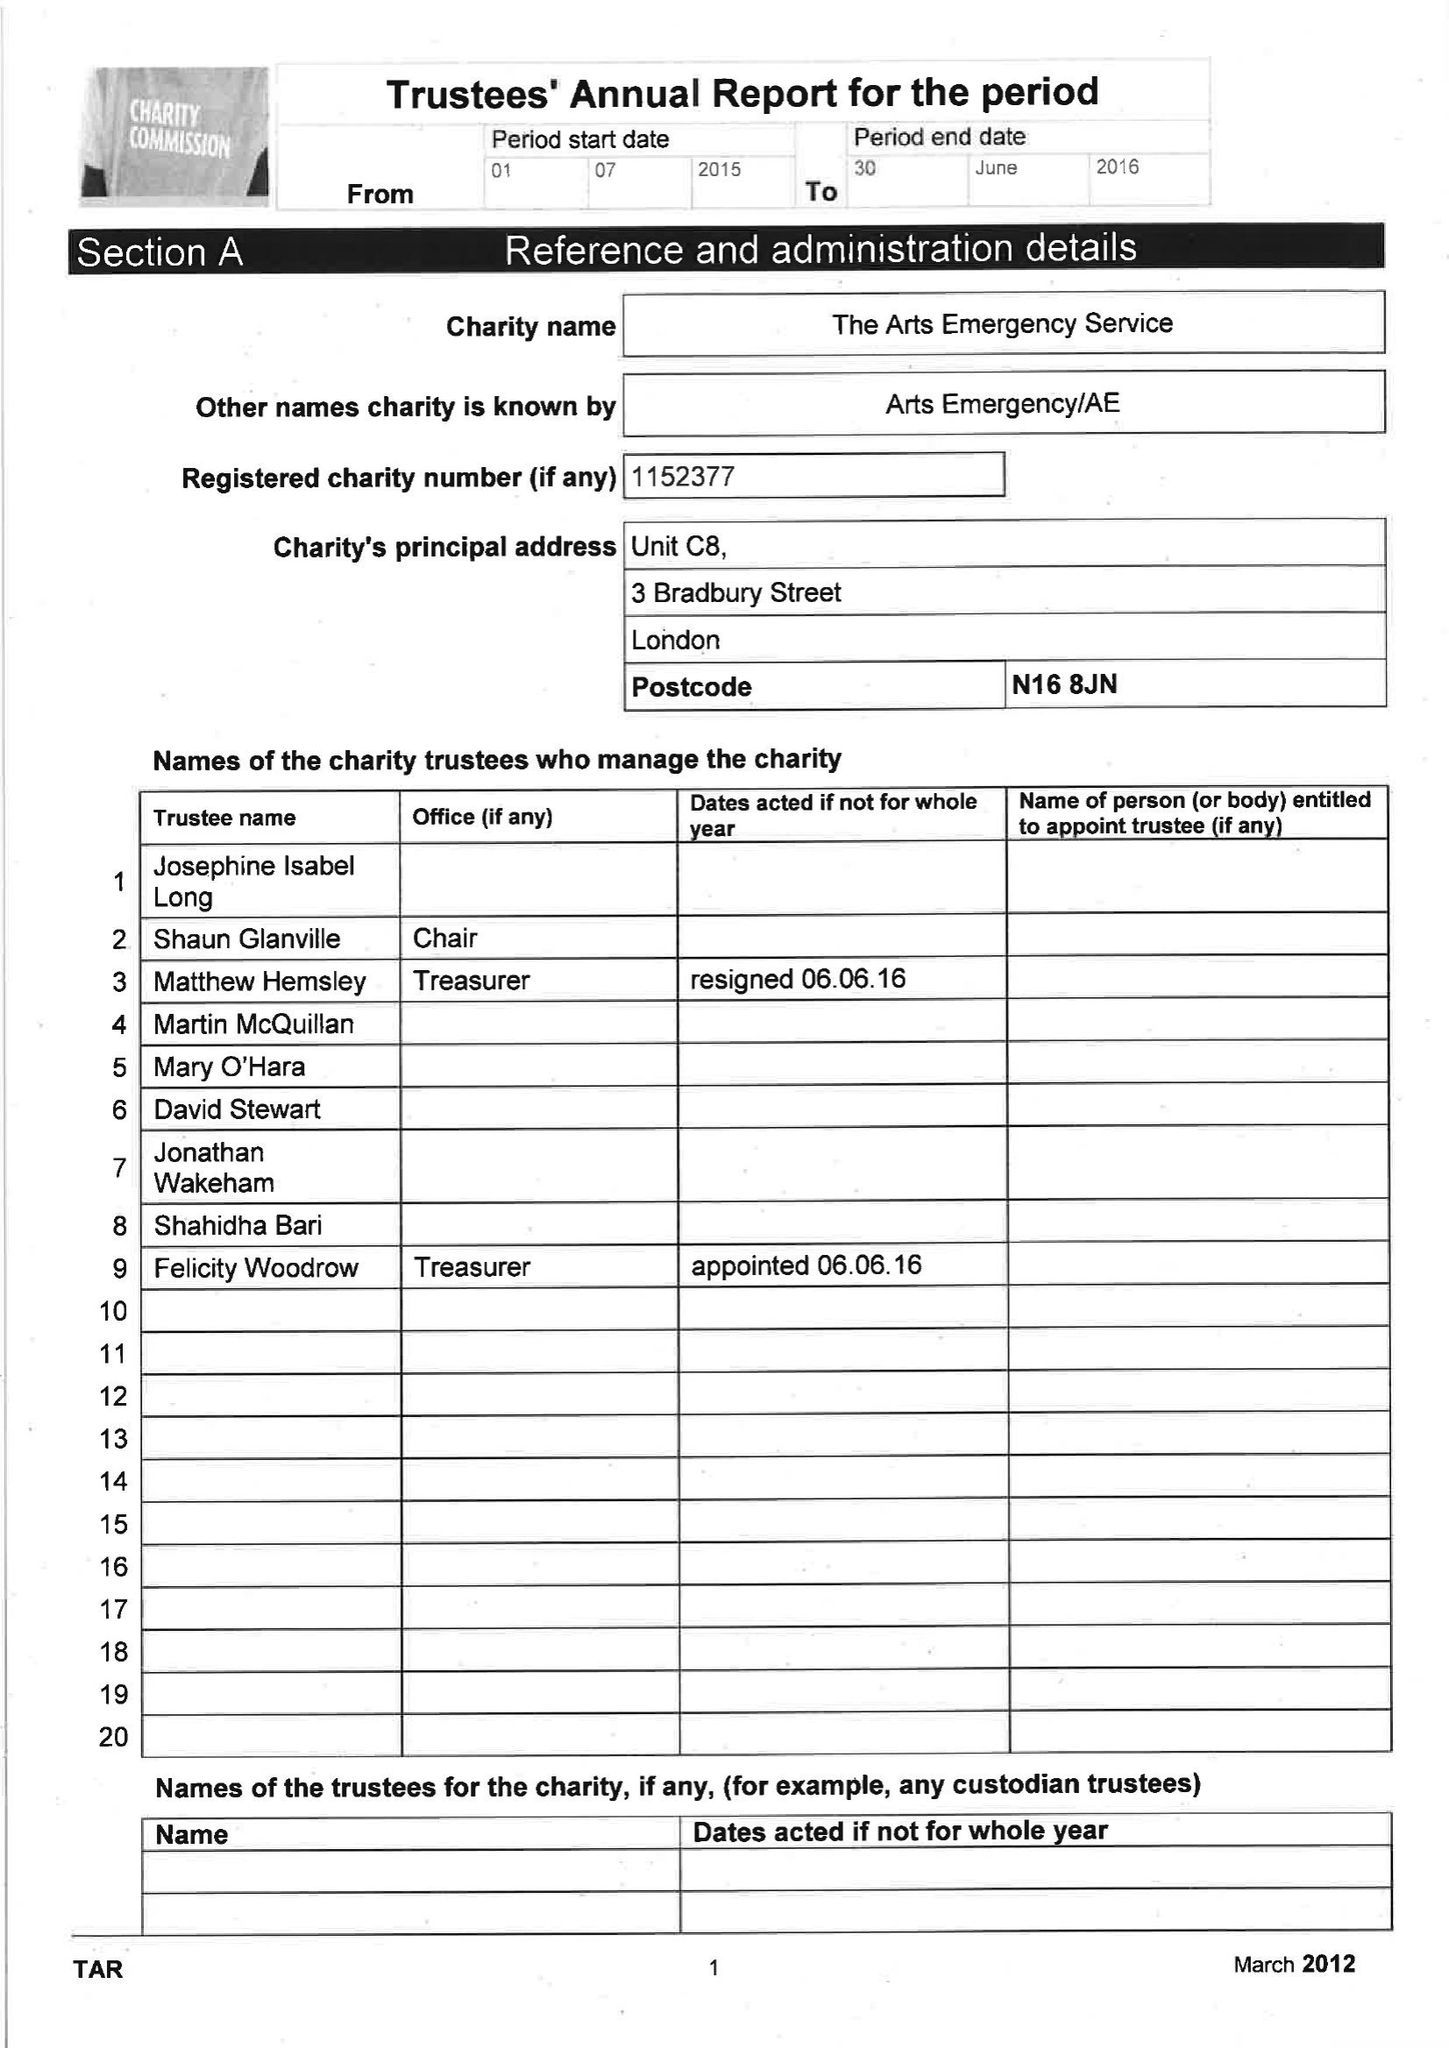What is the value for the spending_annually_in_british_pounds?
Answer the question using a single word or phrase. 87594.00 